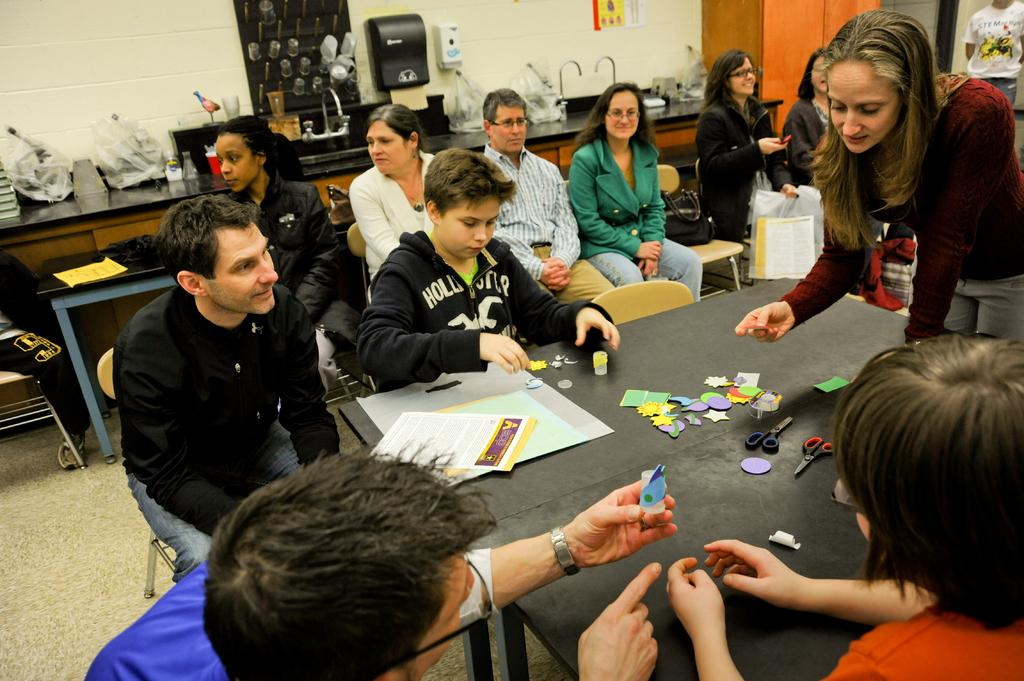What are the people in the image doing? There is a group of people sitting in the middle of the image. What are the people sitting on? The people are sitting on chairs. What can be seen on the right side of the image? There is a woman standing on the right side of the image, and there are scissors on a table. What type of plants can be smelled in the image? There are no plants present in the image, so it is not possible to determine what they might smell like. 